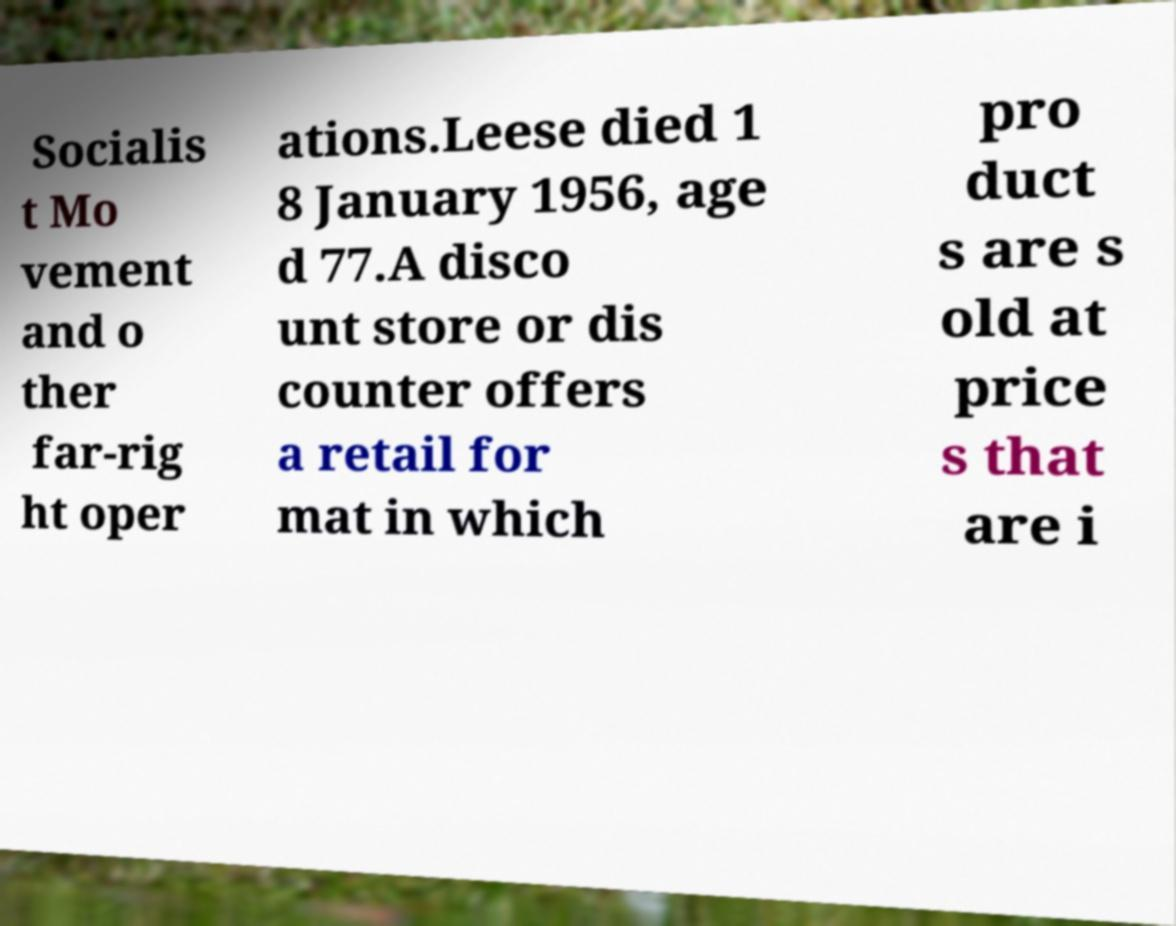Please read and relay the text visible in this image. What does it say? Socialis t Mo vement and o ther far-rig ht oper ations.Leese died 1 8 January 1956, age d 77.A disco unt store or dis counter offers a retail for mat in which pro duct s are s old at price s that are i 